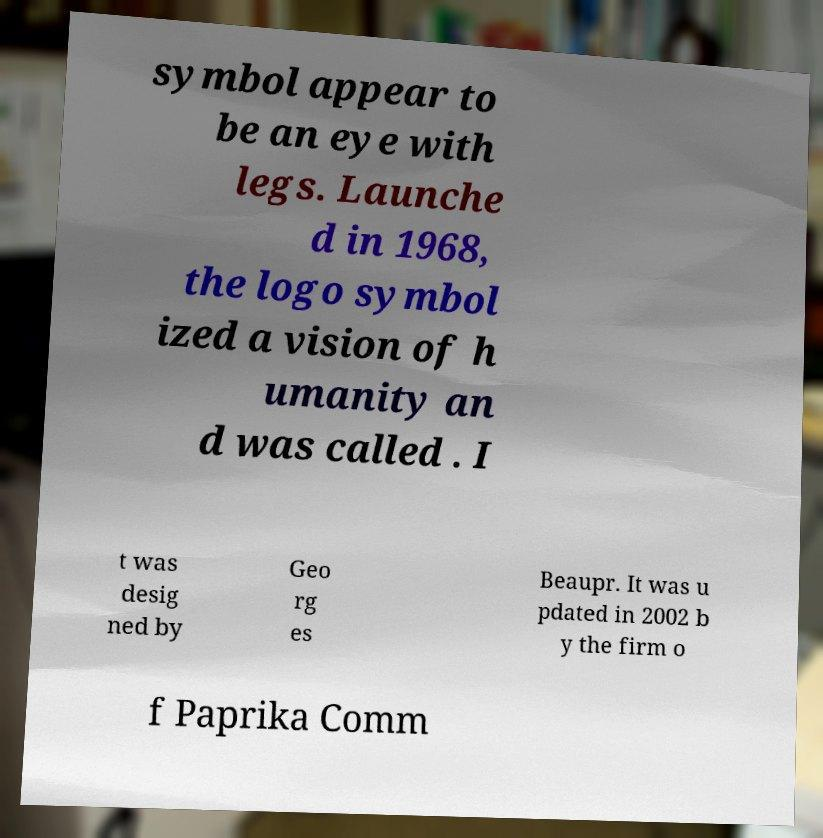Please identify and transcribe the text found in this image. symbol appear to be an eye with legs. Launche d in 1968, the logo symbol ized a vision of h umanity an d was called . I t was desig ned by Geo rg es Beaupr. It was u pdated in 2002 b y the firm o f Paprika Comm 